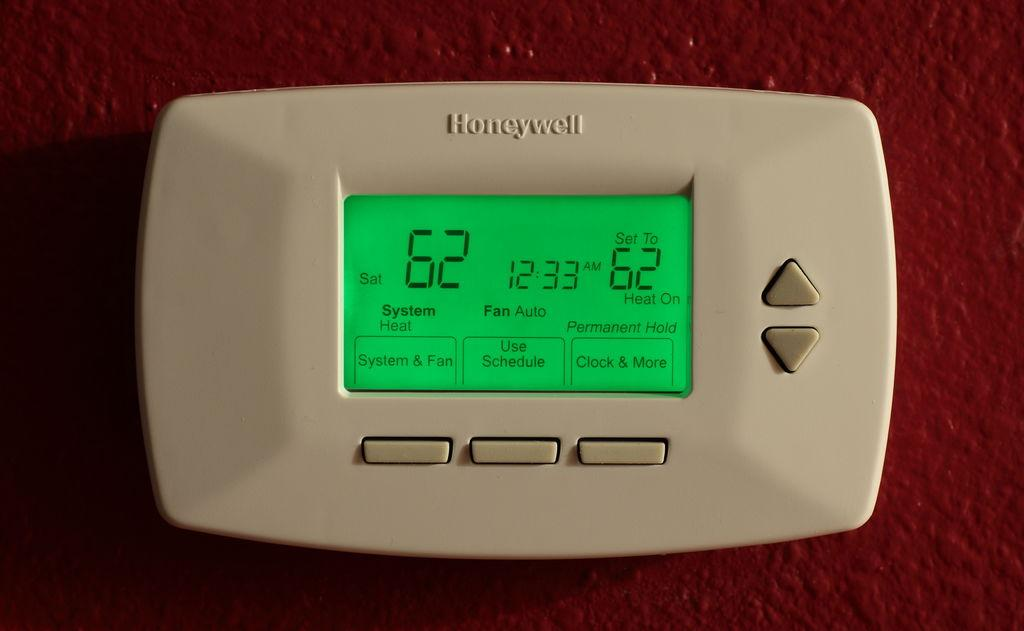<image>
Describe the image concisely. A white honeywell thermostat set to heat to 62. 